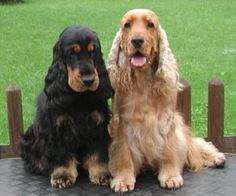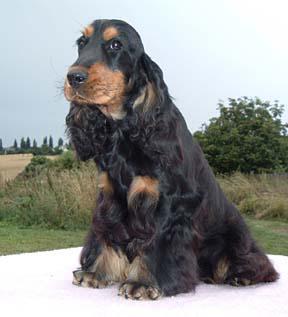The first image is the image on the left, the second image is the image on the right. Analyze the images presented: Is the assertion "The right image contains at least three dogs." valid? Answer yes or no. No. The first image is the image on the left, the second image is the image on the right. Examine the images to the left and right. Is the description "A black-and-tan dog sits upright on the left of a golden haired dog that also sits upright." accurate? Answer yes or no. Yes. 